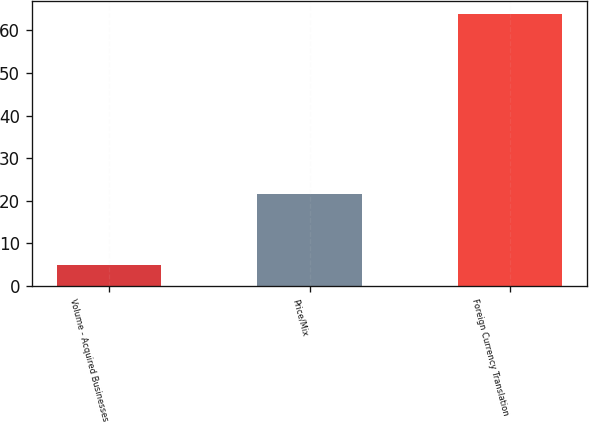Convert chart to OTSL. <chart><loc_0><loc_0><loc_500><loc_500><bar_chart><fcel>Volume - Acquired Businesses<fcel>Price/Mix<fcel>Foreign Currency Translation<nl><fcel>5<fcel>21.5<fcel>63.8<nl></chart> 